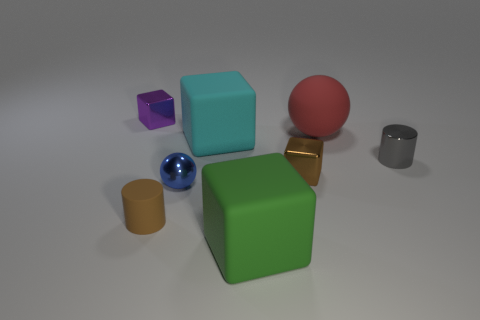Is there a purple metallic object that is in front of the tiny shiny object that is on the left side of the cylinder in front of the tiny brown metal thing?
Offer a terse response. No. How big is the gray cylinder?
Offer a very short reply. Small. What number of other red things have the same size as the red matte thing?
Your response must be concise. 0. There is another large thing that is the same shape as the blue object; what is it made of?
Your answer should be compact. Rubber. What is the shape of the thing that is both in front of the small metallic ball and right of the big cyan cube?
Ensure brevity in your answer.  Cube. There is a blue thing that is left of the big red sphere; what is its shape?
Ensure brevity in your answer.  Sphere. What number of things are on the right side of the tiny brown shiny object and in front of the tiny blue shiny ball?
Make the answer very short. 0. There is a green block; is its size the same as the shiny cube right of the purple block?
Your answer should be compact. No. There is a metallic cube in front of the small cylinder that is on the right side of the cyan thing behind the small shiny cylinder; what size is it?
Keep it short and to the point. Small. What is the size of the brown object in front of the tiny brown metal cube?
Offer a very short reply. Small. 